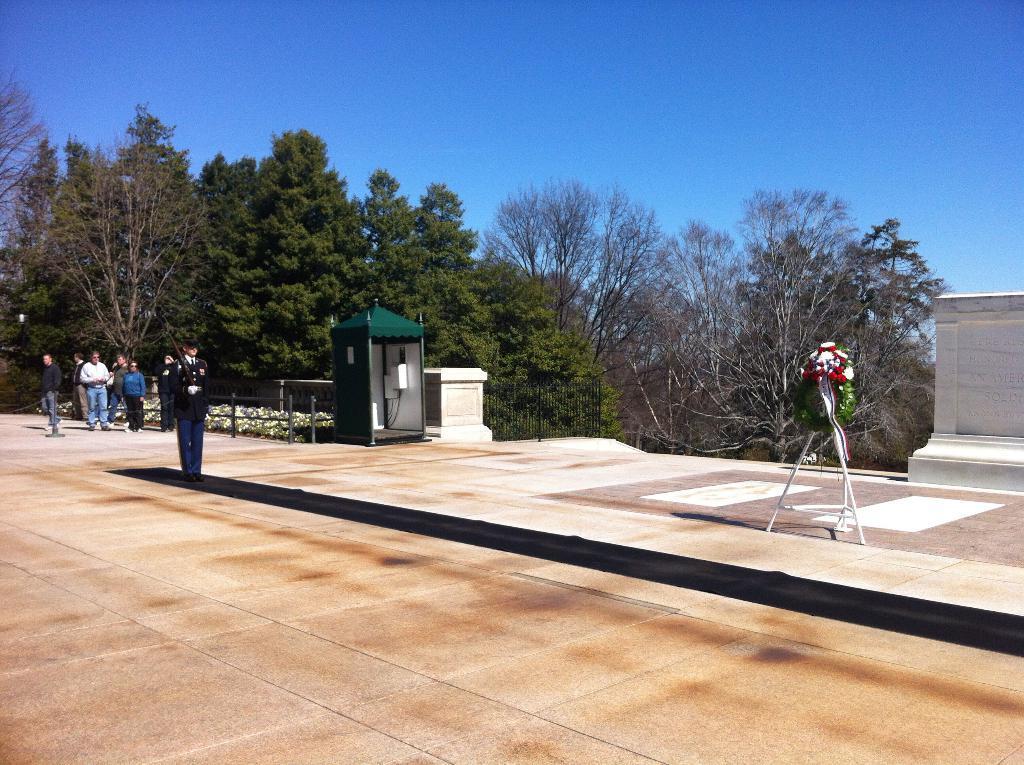How would you summarize this image in a sentence or two? In this picture in the center there is a person standing. In the background there are trees, there are persons, there is a railing and there is a wall and there is an object which is green in colour. On the right side there are flowers on the stand and there is a wall. 